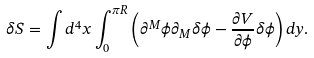<formula> <loc_0><loc_0><loc_500><loc_500>\delta S = \int d ^ { 4 } x \int _ { 0 } ^ { \pi R } \left ( \partial ^ { M } \phi \partial _ { M } \delta \phi - \frac { \partial V } { \partial \phi } \delta \phi \right ) d y .</formula> 